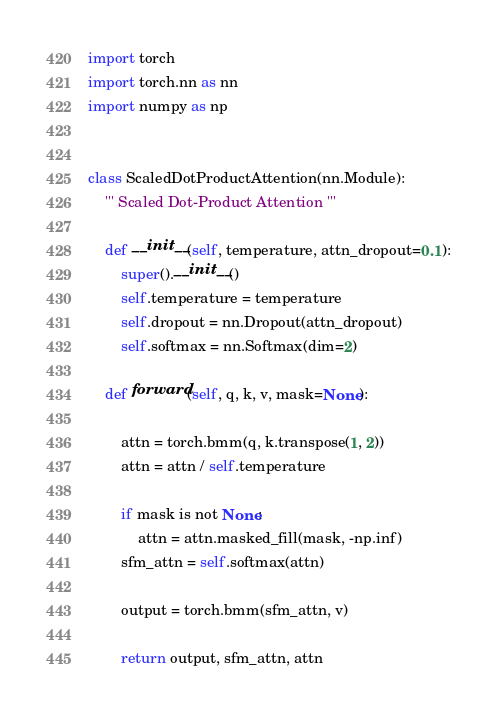<code> <loc_0><loc_0><loc_500><loc_500><_Python_>import torch
import torch.nn as nn
import numpy as np


class ScaledDotProductAttention(nn.Module):
    ''' Scaled Dot-Product Attention '''

    def __init__(self, temperature, attn_dropout=0.1):
        super().__init__()
        self.temperature = temperature
        self.dropout = nn.Dropout(attn_dropout)
        self.softmax = nn.Softmax(dim=2)

    def forward(self, q, k, v, mask=None):

        attn = torch.bmm(q, k.transpose(1, 2))
        attn = attn / self.temperature

        if mask is not None:
            attn = attn.masked_fill(mask, -np.inf)
        sfm_attn = self.softmax(attn)

        output = torch.bmm(sfm_attn, v)

        return output, sfm_attn, attn
</code> 